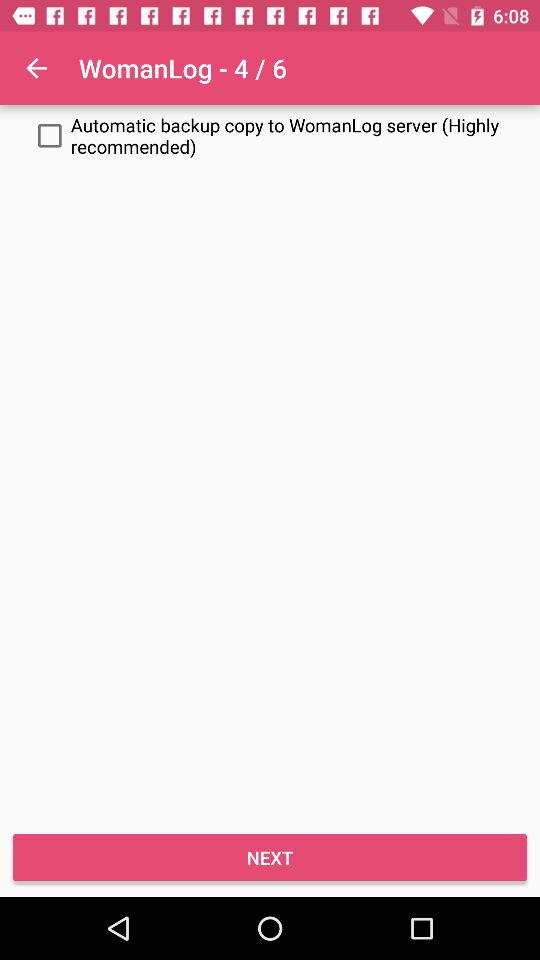Currently we are on what page of Womanlog? We are on the 4th page. 